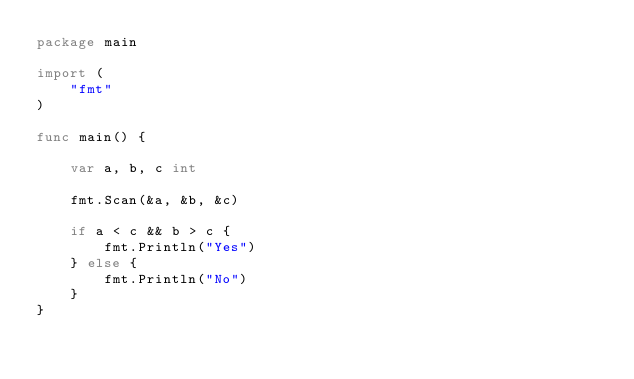Convert code to text. <code><loc_0><loc_0><loc_500><loc_500><_Go_>package main

import (
    "fmt"
)

func main() {

    var a, b, c int

    fmt.Scan(&a, &b, &c)

    if a < c && b > c {
        fmt.Println("Yes")
    } else {
        fmt.Println("No")
    }
}</code> 